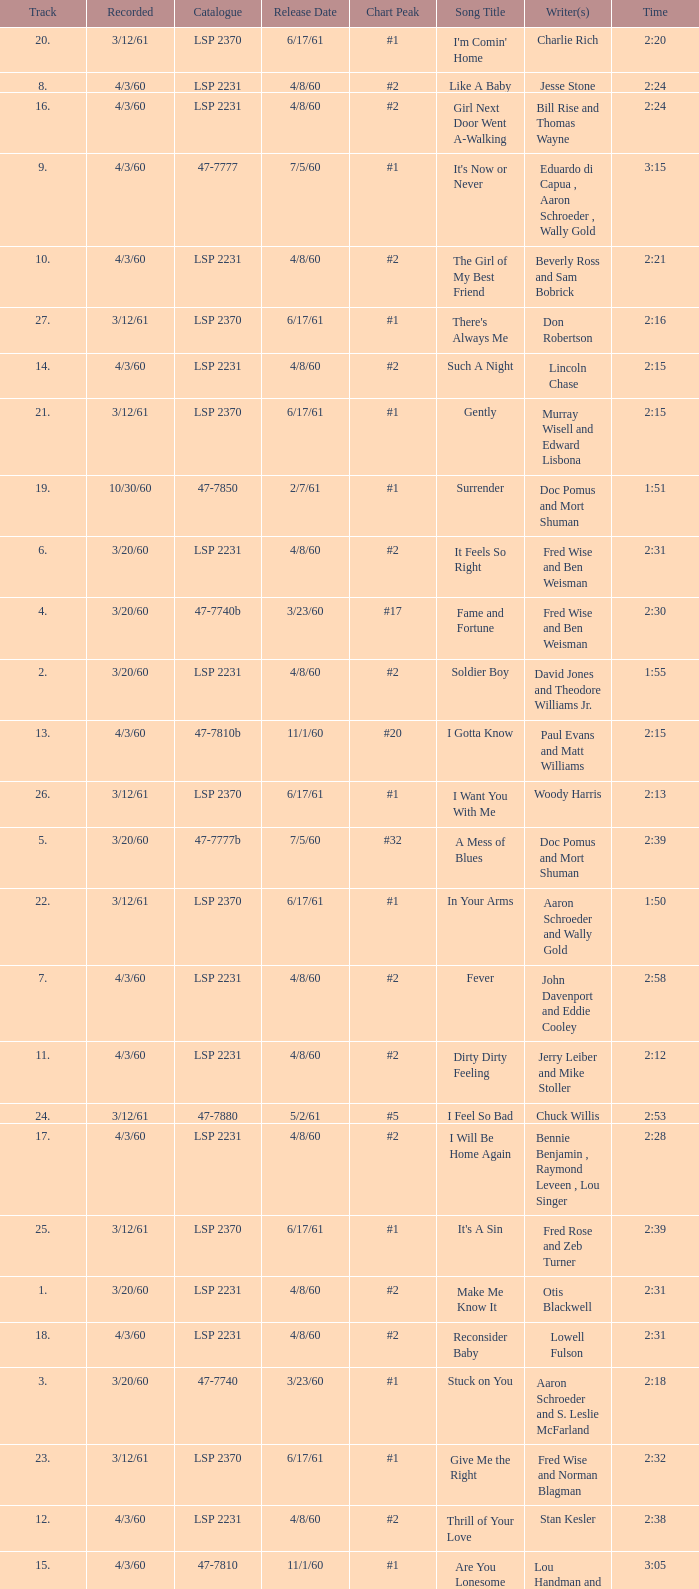What is the time of songs that have the writer Aaron Schroeder and Wally Gold? 1:50. 